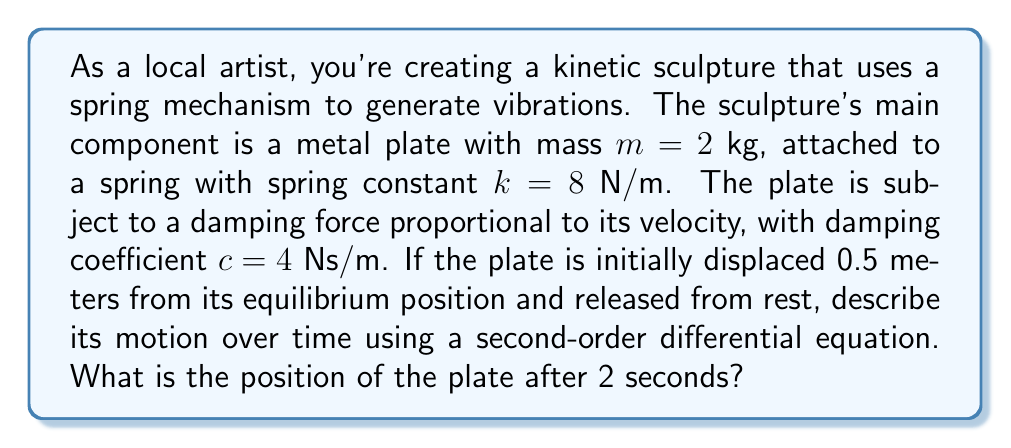What is the answer to this math problem? To solve this problem, we'll follow these steps:

1) First, we need to set up the second-order differential equation that describes the motion of the plate. The general form of this equation is:

   $$m\frac{d^2x}{dt^2} + c\frac{dx}{dt} + kx = 0$$

   Where $x$ is the displacement from equilibrium, $t$ is time, $m$ is mass, $c$ is the damping coefficient, and $k$ is the spring constant.

2) Substituting the given values:

   $$2\frac{d^2x}{dt^2} + 4\frac{dx}{dt} + 8x = 0$$

3) To solve this, we need to find the characteristic equation:

   $$2r^2 + 4r + 8 = 0$$

4) Solving this quadratic equation:

   $$r = \frac{-4 \pm \sqrt{16 - 64}}{4} = -1 \pm i\sqrt{3}$$

5) The general solution to this equation is:

   $$x(t) = e^{-t}(A\cos(\sqrt{3}t) + B\sin(\sqrt{3}t))$$

   Where $A$ and $B$ are constants determined by initial conditions.

6) Given initial conditions: $x(0) = 0.5$ and $x'(0) = 0$

   From $x(0) = 0.5$, we get $A = 0.5$

   From $x'(0) = 0$, we get $B = \frac{1}{2\sqrt{3}}$

7) Therefore, the specific solution is:

   $$x(t) = e^{-t}(0.5\cos(\sqrt{3}t) + \frac{1}{2\sqrt{3}}\sin(\sqrt{3}t))$$

8) To find the position after 2 seconds, we evaluate $x(2)$:

   $$x(2) = e^{-2}(0.5\cos(2\sqrt{3}) + \frac{1}{2\sqrt{3}}\sin(2\sqrt{3}))$$

9) Calculating this (you may use a calculator):

   $$x(2) \approx 0.0432$$ meters
Answer: The position of the plate after 2 seconds is approximately 0.0432 meters from its equilibrium position. 